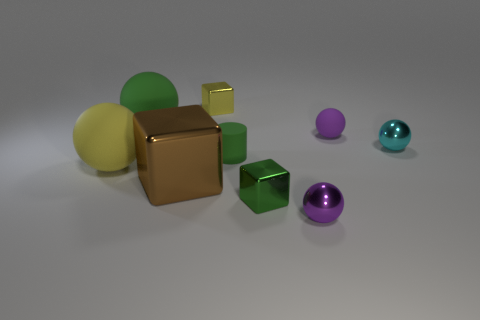Subtract all green spheres. Subtract all purple cubes. How many spheres are left? 4 Subtract all brown spheres. How many green blocks are left? 1 Add 2 browns. How many things exist? 0 Subtract all cylinders. Subtract all big spheres. How many objects are left? 6 Add 7 big yellow rubber spheres. How many big yellow rubber spheres are left? 8 Add 9 tiny green shiny things. How many tiny green shiny things exist? 10 Add 1 small things. How many objects exist? 10 Subtract all cyan balls. How many balls are left? 4 Subtract all small cyan balls. How many balls are left? 4 Subtract 1 brown cubes. How many objects are left? 8 